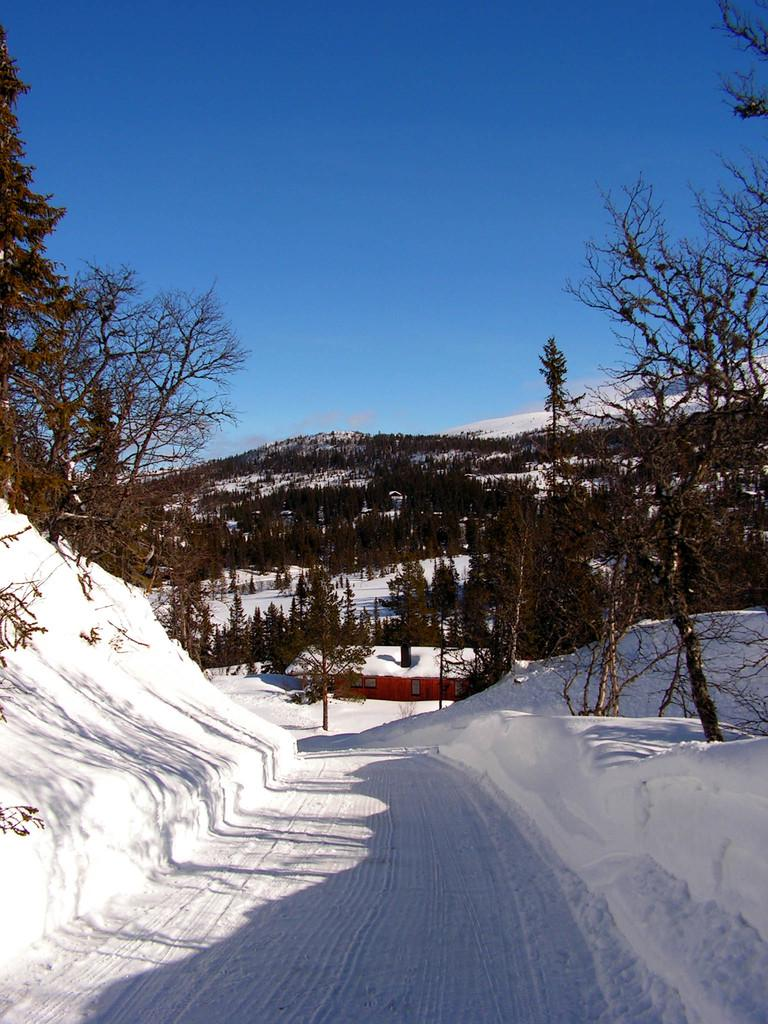What type of weather condition is depicted in the image? There is snow in the image, indicating a winter scene. What structure can be seen in the background of the image? There is a house in the background of the image, and it is covered with snow. What type of vegetation is visible in the background of the image? There are trees in the background of the image. What color is the sky in the image? The sky is blue in the image. How many sugar cubes are on the goat's head in the image? There is no goat or sugar cubes present in the image; it features a snowy scene with a house and trees in the background. 